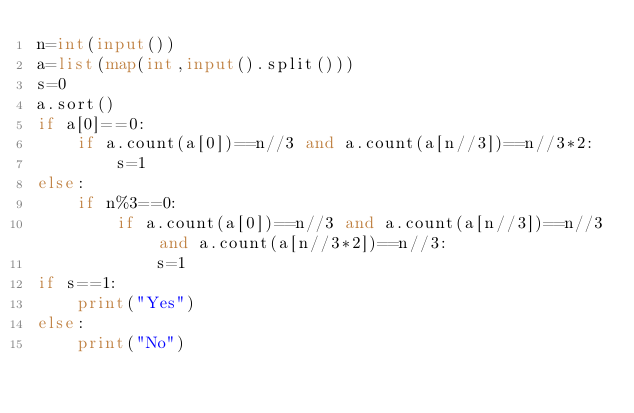<code> <loc_0><loc_0><loc_500><loc_500><_Python_>n=int(input())
a=list(map(int,input().split()))
s=0
a.sort()
if a[0]==0:
    if a.count(a[0])==n//3 and a.count(a[n//3])==n//3*2:
        s=1
else:
    if n%3==0:
        if a.count(a[0])==n//3 and a.count(a[n//3])==n//3 and a.count(a[n//3*2])==n//3:
            s=1
if s==1:
    print("Yes")
else:
    print("No")</code> 